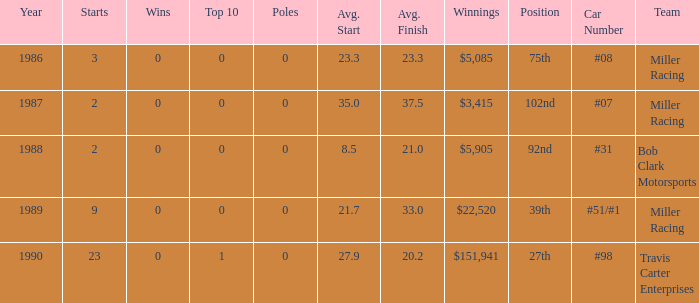What are the racing teams for which the average finish is 23.3? #08 Miller Racing. 